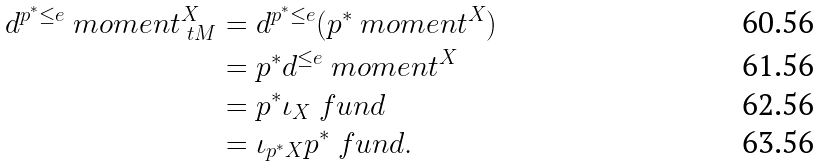<formula> <loc_0><loc_0><loc_500><loc_500>d ^ { p ^ { * } \leq e } \ m o m e n t _ { \ t M } ^ { X } & = d ^ { p ^ { * } \leq e } ( p ^ { * } \ m o m e n t ^ { X } ) \\ & = p ^ { * } d ^ { \leq e } \ m o m e n t ^ { X } \\ & = p ^ { * } \iota _ { X } \ f u n d \\ & = \iota _ { p ^ { * } X } p ^ { * } \ f u n d .</formula> 